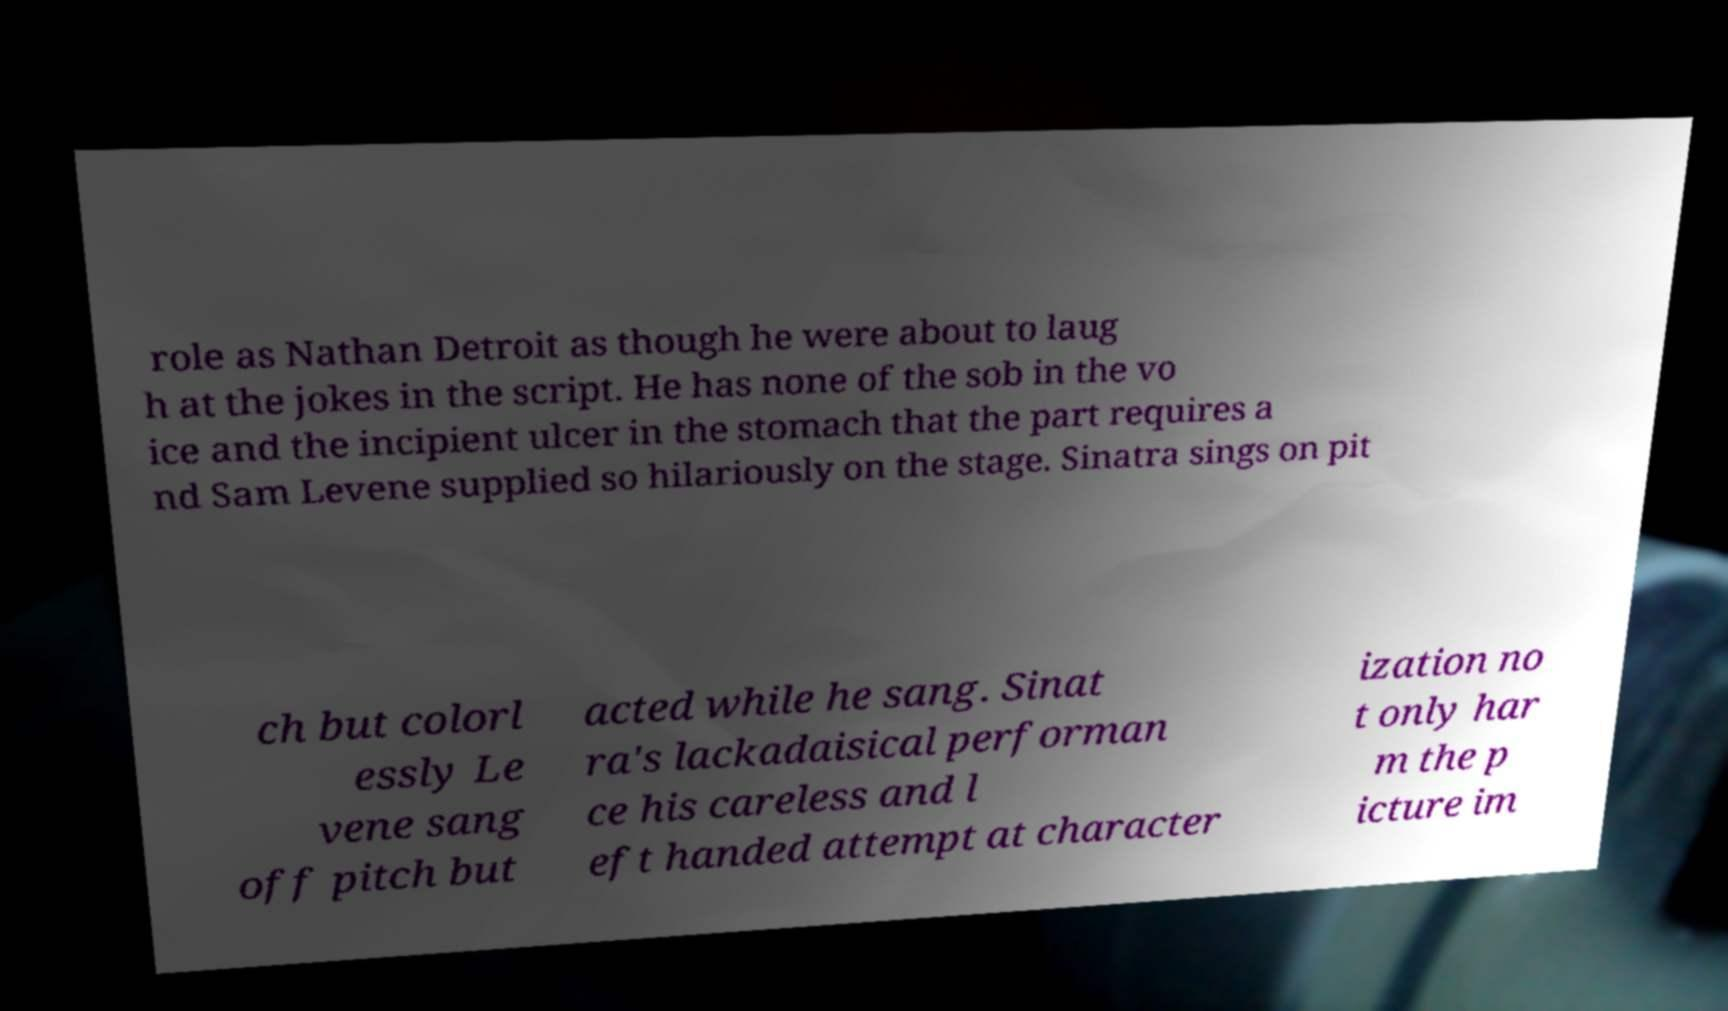What messages or text are displayed in this image? I need them in a readable, typed format. role as Nathan Detroit as though he were about to laug h at the jokes in the script. He has none of the sob in the vo ice and the incipient ulcer in the stomach that the part requires a nd Sam Levene supplied so hilariously on the stage. Sinatra sings on pit ch but colorl essly Le vene sang off pitch but acted while he sang. Sinat ra's lackadaisical performan ce his careless and l eft handed attempt at character ization no t only har m the p icture im 